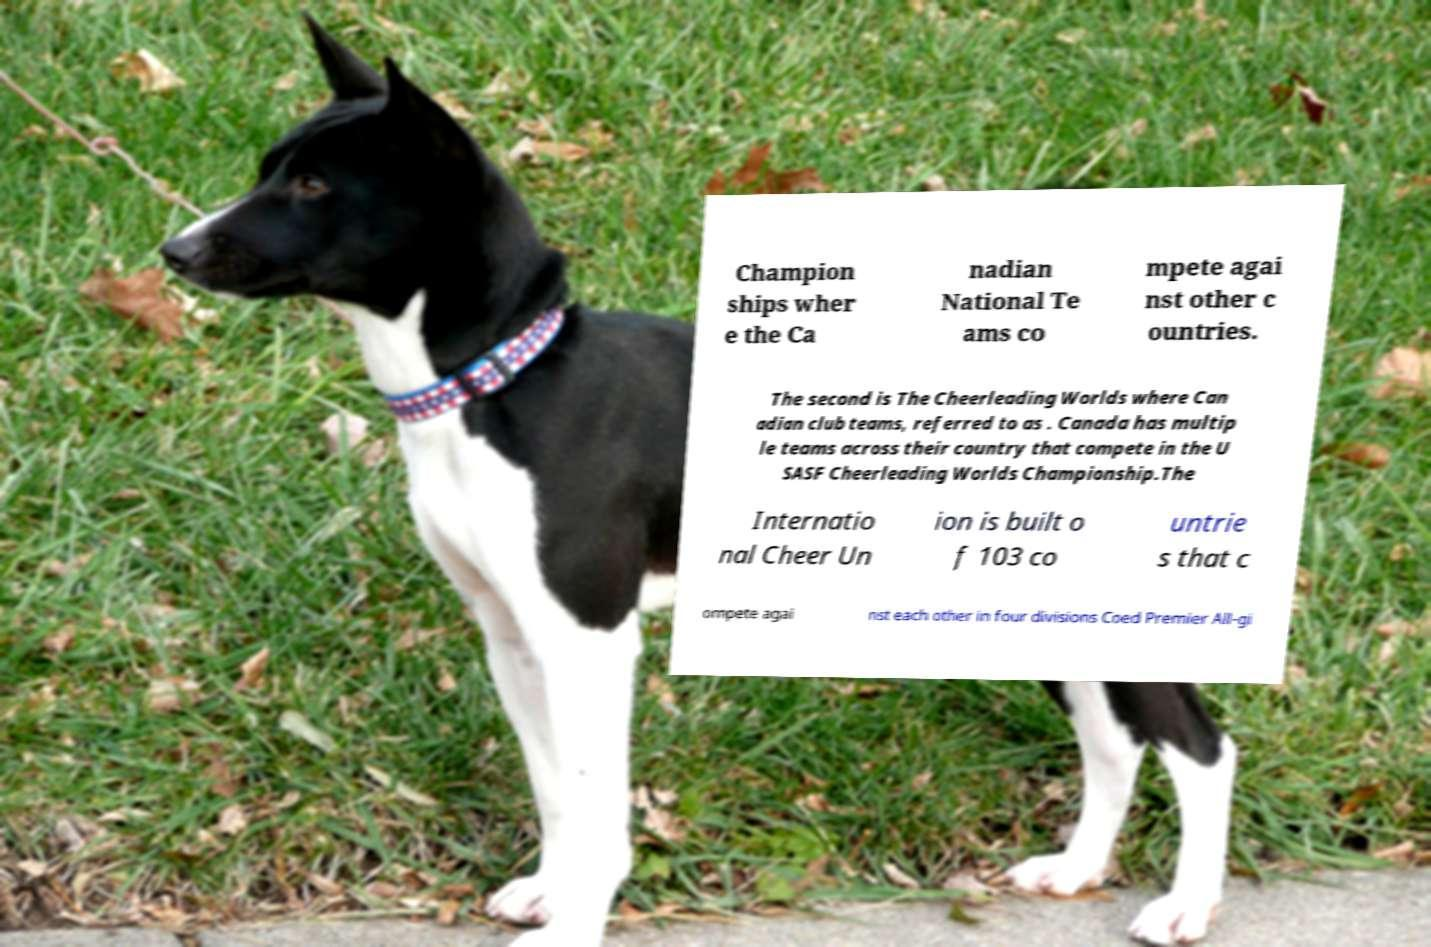I need the written content from this picture converted into text. Can you do that? Champion ships wher e the Ca nadian National Te ams co mpete agai nst other c ountries. The second is The Cheerleading Worlds where Can adian club teams, referred to as . Canada has multip le teams across their country that compete in the U SASF Cheerleading Worlds Championship.The Internatio nal Cheer Un ion is built o f 103 co untrie s that c ompete agai nst each other in four divisions Coed Premier All-gi 